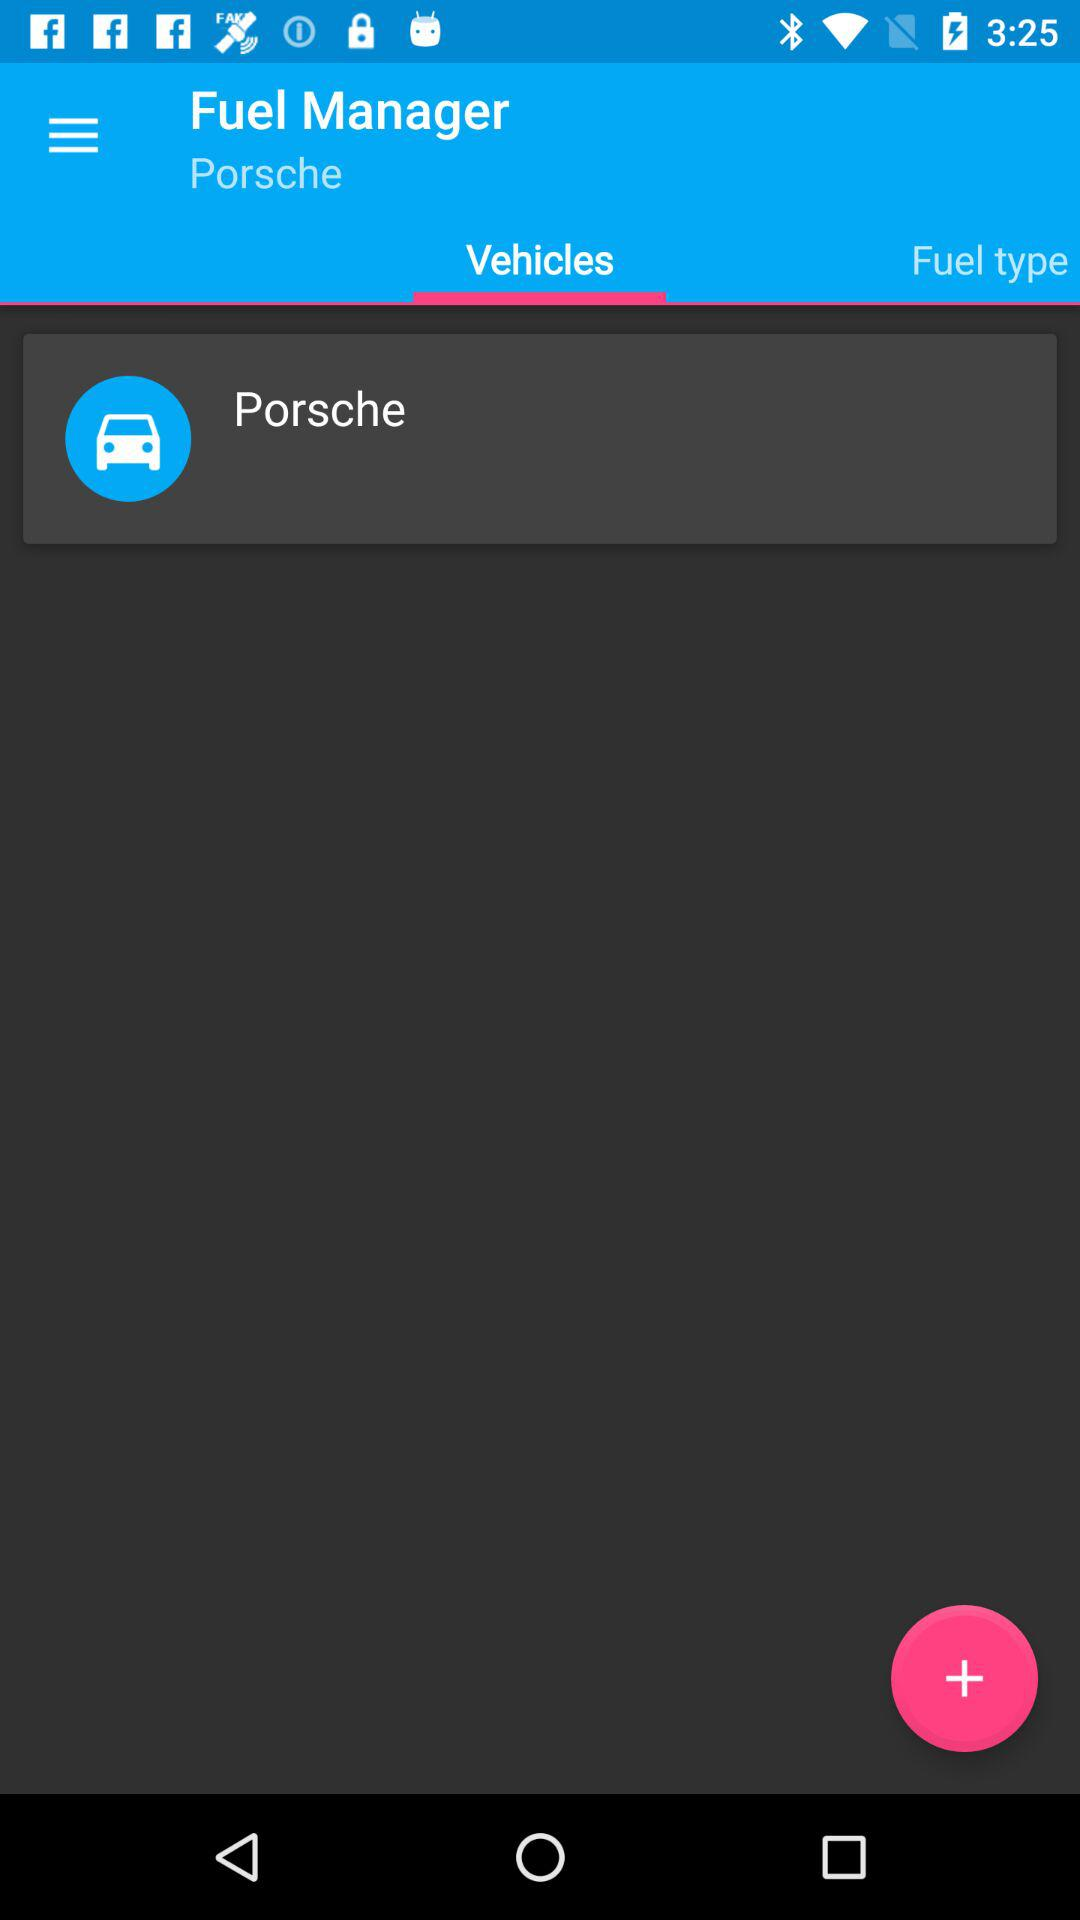Which tab is selected? The selected tab is "Vehicles". 